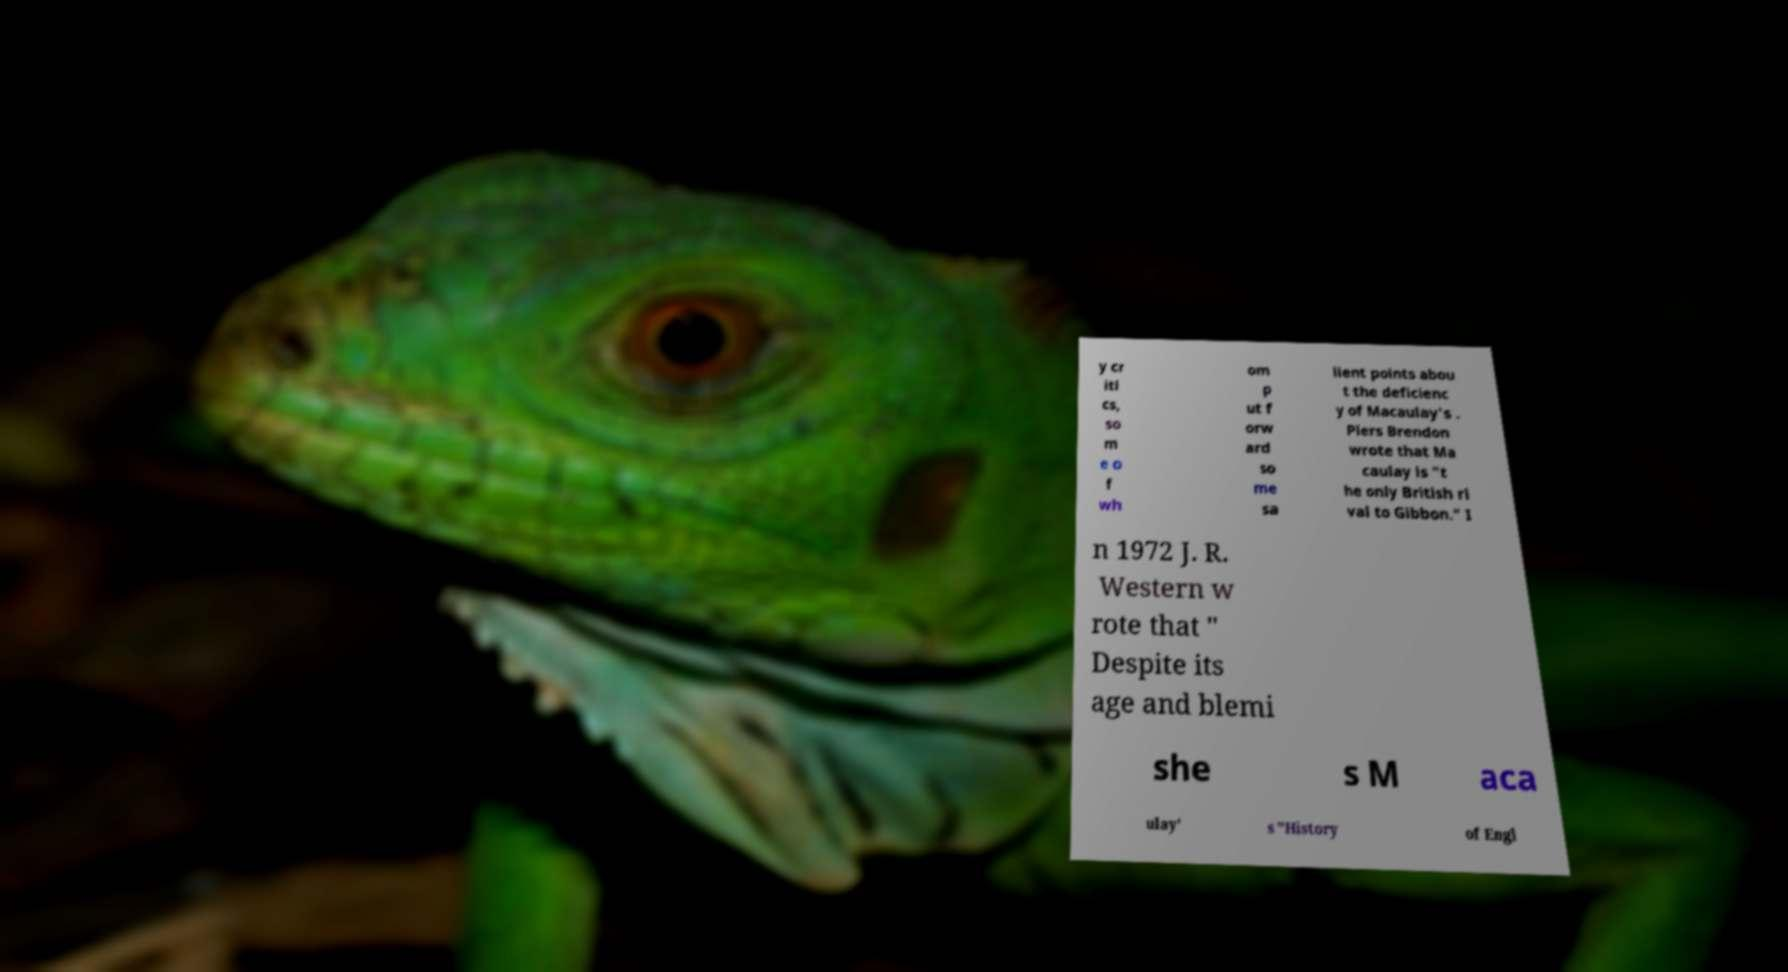Please read and relay the text visible in this image. What does it say? y cr iti cs, so m e o f wh om p ut f orw ard so me sa lient points abou t the deficienc y of Macaulay's . Piers Brendon wrote that Ma caulay is "t he only British ri val to Gibbon." I n 1972 J. R. Western w rote that " Despite its age and blemi she s M aca ulay' s "History of Engl 